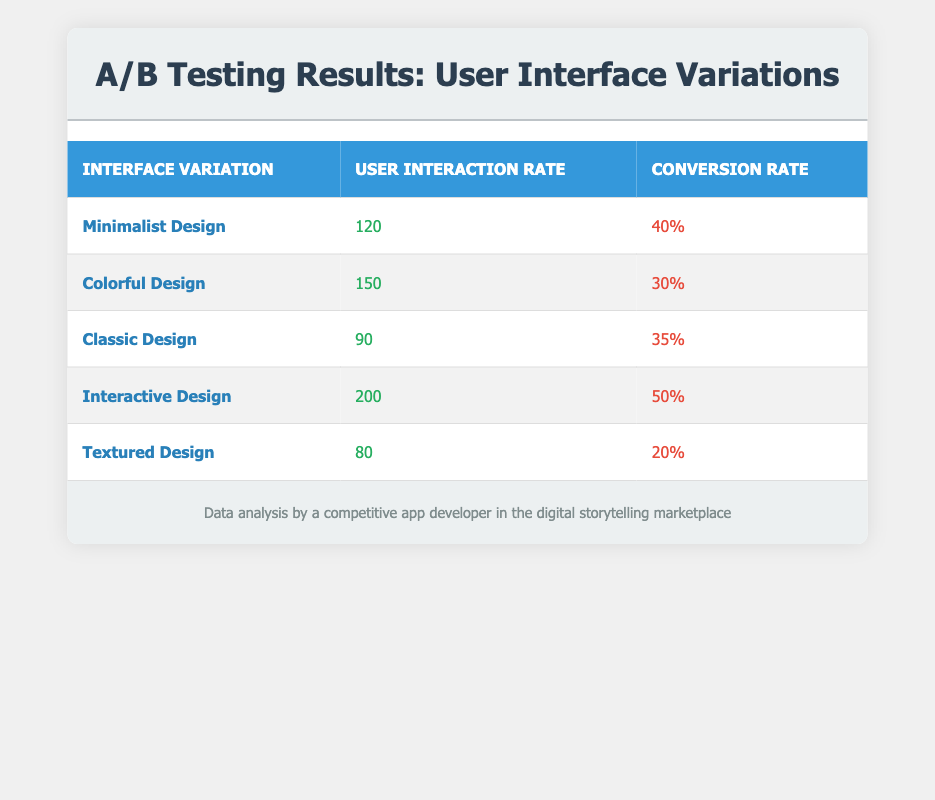What is the highest user interaction rate among the interface variations? The highest user interaction rate is listed in the table under "Interactive Design," which has a value of 200.
Answer: 200 Which interface variation has the lowest conversion rate? Referring to the table, the "Textured Design" has the lowest conversion rate, which is 20%.
Answer: 20% What is the conversion rate of the "Colorful Design"? Looking at the table, the "Colorful Design" has a conversion rate of 30%.
Answer: 30% What is the average user interaction rate across all interface variations? The user interaction rates are 120, 150, 90, 200, and 80. Adding these values gives 120 + 150 + 90 + 200 + 80 = 640. Dividing by the number of variations (5) gives an average of 640 / 5 = 128.
Answer: 128 Did "Interactive Design" have a higher conversion rate than "Minimalist Design"? The table shows "Interactive Design" at 50% and "Minimalist Design" at 40%. Since 50% is greater than 40%, the statement is true.
Answer: Yes What is the sum of user interaction rates for "Classic Design" and "Textured Design"? The user interaction rates for "Classic Design" and "Textured Design" are 90 and 80, respectively. Adding these gives 90 + 80 = 170.
Answer: 170 How many interface variations had a user interaction rate greater than 100? From the table, the variations with a rate greater than 100 are "Minimalist Design" (120), "Colorful Design" (150), and "Interactive Design" (200), totaling three variations.
Answer: 3 Is the conversion rate of "Classic Design" higher than 30%? The table shows the conversion rate for "Classic Design" is 35%, which is higher than 30%. Therefore, the statement is true.
Answer: Yes What is the difference in conversion rates between "Interactive Design" and "Textured Design"? The conversion rate for "Interactive Design" is 50%, and for "Textured Design," it is 20%. The difference is calculated as 50% - 20% = 30%.
Answer: 30% 